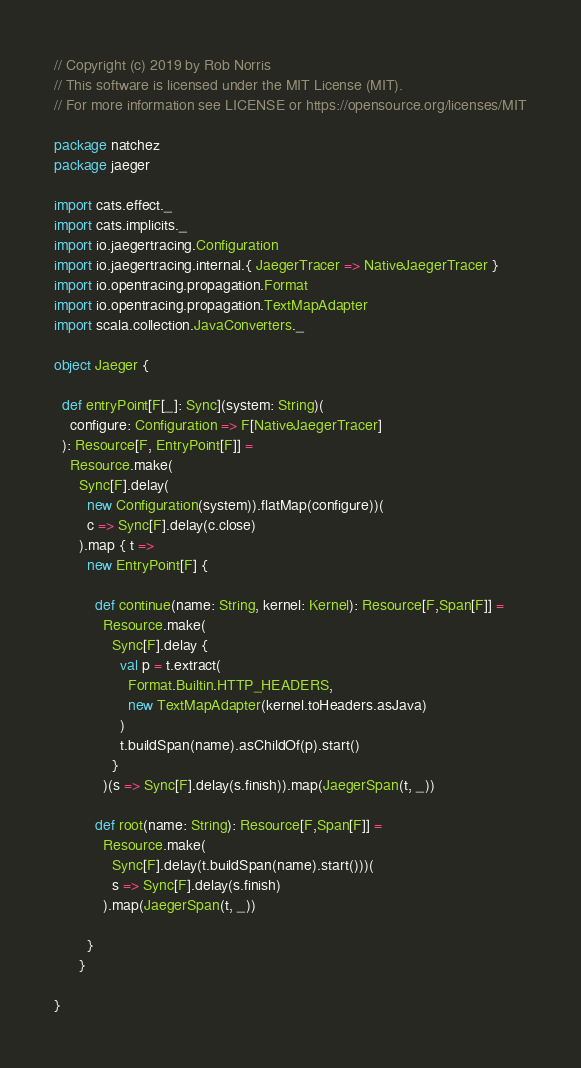Convert code to text. <code><loc_0><loc_0><loc_500><loc_500><_Scala_>// Copyright (c) 2019 by Rob Norris
// This software is licensed under the MIT License (MIT).
// For more information see LICENSE or https://opensource.org/licenses/MIT

package natchez
package jaeger

import cats.effect._
import cats.implicits._
import io.jaegertracing.Configuration
import io.jaegertracing.internal.{ JaegerTracer => NativeJaegerTracer }
import io.opentracing.propagation.Format
import io.opentracing.propagation.TextMapAdapter
import scala.collection.JavaConverters._

object Jaeger {

  def entryPoint[F[_]: Sync](system: String)(
    configure: Configuration => F[NativeJaegerTracer]
  ): Resource[F, EntryPoint[F]] =
    Resource.make(
      Sync[F].delay(
        new Configuration(system)).flatMap(configure))(
        c => Sync[F].delay(c.close)
      ).map { t =>
        new EntryPoint[F] {

          def continue(name: String, kernel: Kernel): Resource[F,Span[F]] =
            Resource.make(
              Sync[F].delay {
                val p = t.extract(
                  Format.Builtin.HTTP_HEADERS,
                  new TextMapAdapter(kernel.toHeaders.asJava)
                )
                t.buildSpan(name).asChildOf(p).start()
              }
            )(s => Sync[F].delay(s.finish)).map(JaegerSpan(t, _))

          def root(name: String): Resource[F,Span[F]] =
            Resource.make(
              Sync[F].delay(t.buildSpan(name).start()))(
              s => Sync[F].delay(s.finish)
            ).map(JaegerSpan(t, _))

        }
      }

}
</code> 